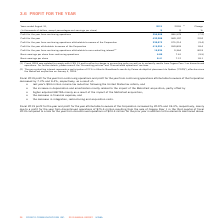According to Cogeco's financial document, What percentage of non-controlling interest represents a participation in Atlantic Broadband? According to the financial document, 21%. The relevant text states: "controlling interest represents a participation of 21% in Atlantic Broadband's results by Caisse de dépôt et placement du Québec ("CDPQ"), effective since..." Also, What was the increase / (decrease) in the profit for the year from continuing operations? According to the financial document, 7.2%. The relevant text states: "ibutable to owners of the Corporation decreased by 7.2% and 9.4%, respectively, as a result of:..." Also, By what percentage did the profit for the year attributable to owners of the Corporation increased by? According to the financial document, 18.4%. The relevant text states: "o owners of the Corporation increased by 20.0% and 18.4%, respectively, mainly due to a profit for the year from discontinued operations of $75.4 million re..." Also, can you calculate: What was the increase / (decrease) in the Profit for the year from continuing operations from 2018 to 2019? Based on the calculation: 356,908 - 384,578, the result is -27670 (in thousands). This is based on the information: "Profit for the year from continuing operations 356,908 384,578 (7.2) t for the year from continuing operations 356,908 384,578 (7.2)..." The key data points involved are: 356,908, 384,578. Also, can you calculate: What was the average Profit for the year between 2018 and 2019? To answer this question, I need to perform calculations using the financial data. The calculation is: (432,288 + 360,197) / 2, which equals 396242.5 (in thousands). This is based on the information: "Profit for the year 432,288 360,197 20.0 Profit for the year 432,288 360,197 20.0..." The key data points involved are: 360,197, 432,288. Also, can you calculate: What was the increase / (decrease) in the Basic earnings per share from continuing operations from 2018 to 2019? Based on the calculation: 6.89 - 7.61, the result is -0.72. This is based on the information: "sic earnings per share from continuing operations 6.89 7.61 (9.5) arnings per share from continuing operations 6.89 7.61 (9.5)..." The key data points involved are: 6.89, 7.61. 